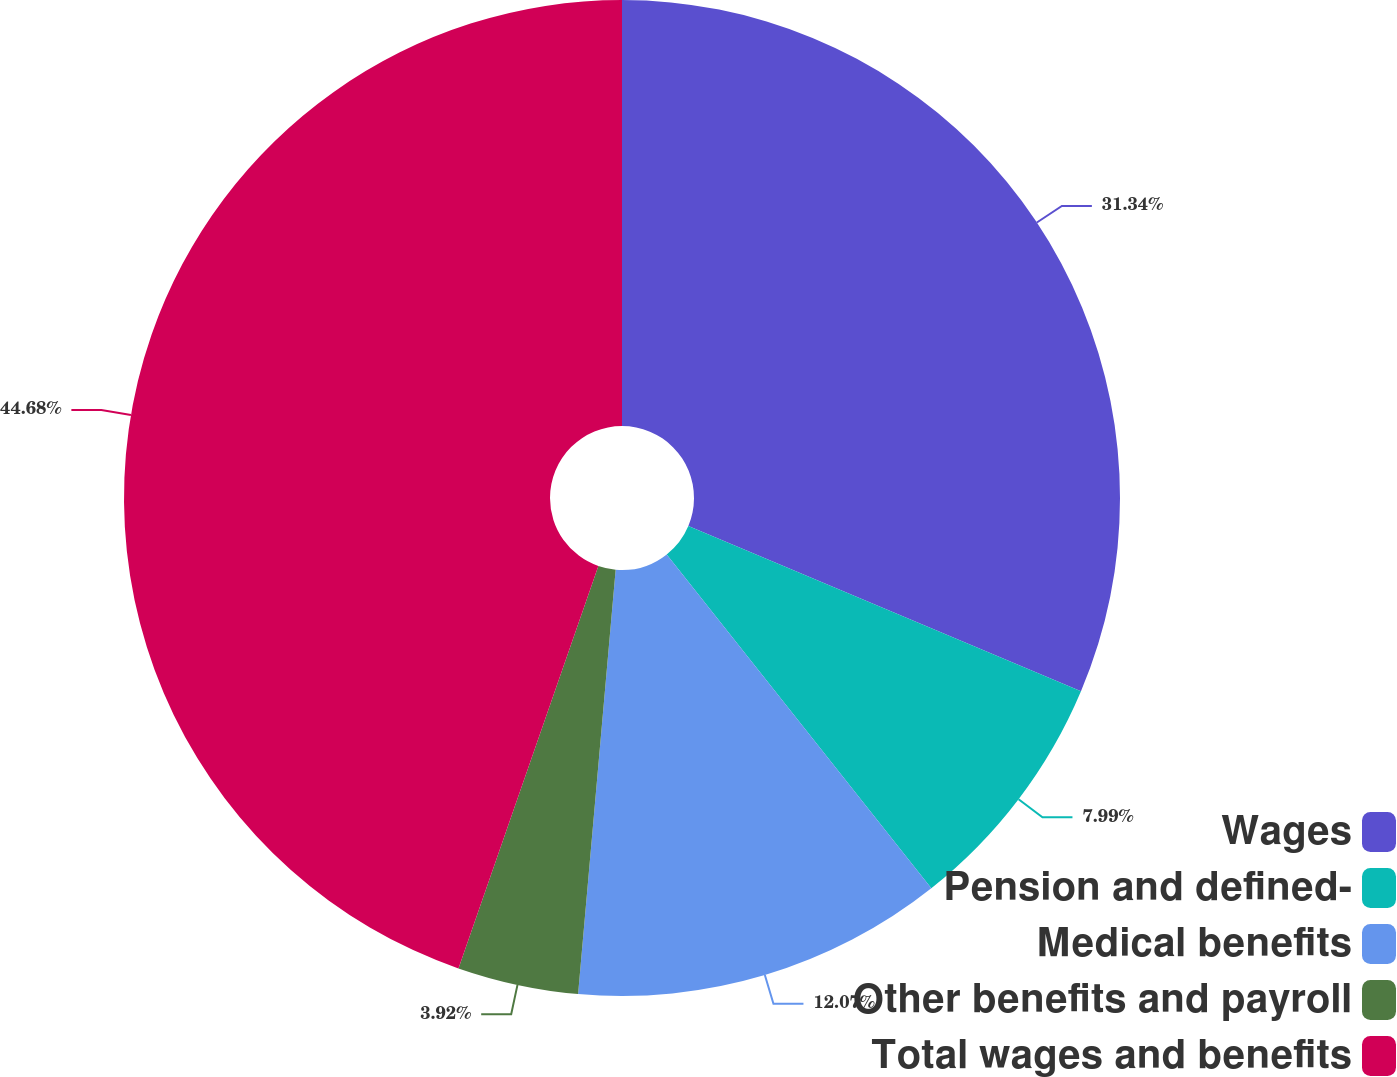Convert chart to OTSL. <chart><loc_0><loc_0><loc_500><loc_500><pie_chart><fcel>Wages<fcel>Pension and defined-<fcel>Medical benefits<fcel>Other benefits and payroll<fcel>Total wages and benefits<nl><fcel>31.34%<fcel>7.99%<fcel>12.07%<fcel>3.92%<fcel>44.67%<nl></chart> 